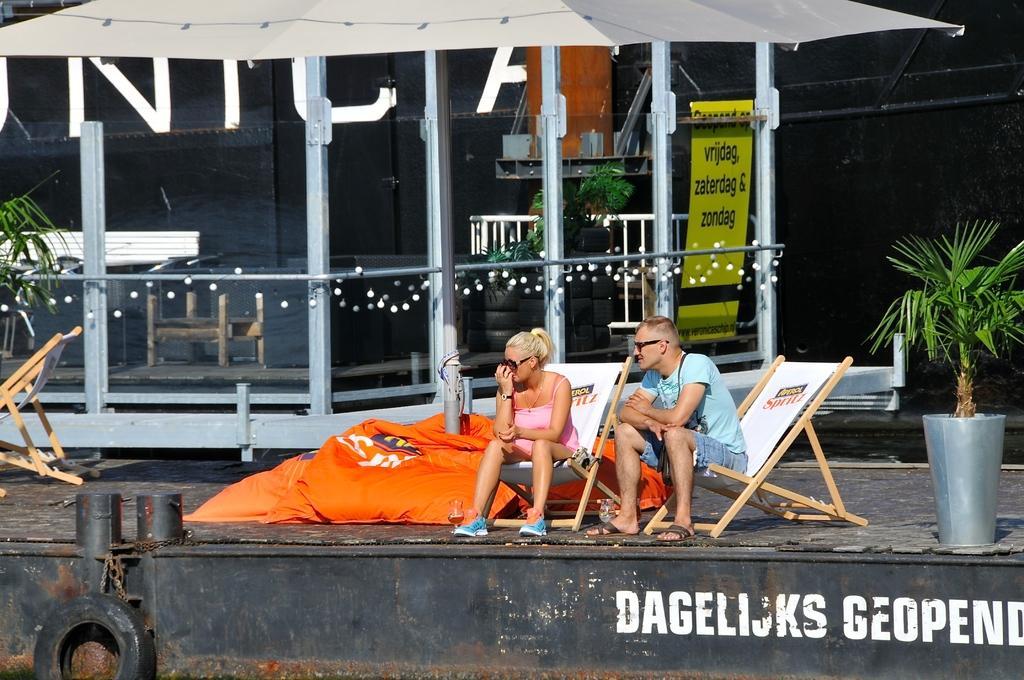Could you give a brief overview of what you see in this image? These two people are sitting on chairs. Here we can see plant and tire. Background there is a banner, lights, tires and plant. 